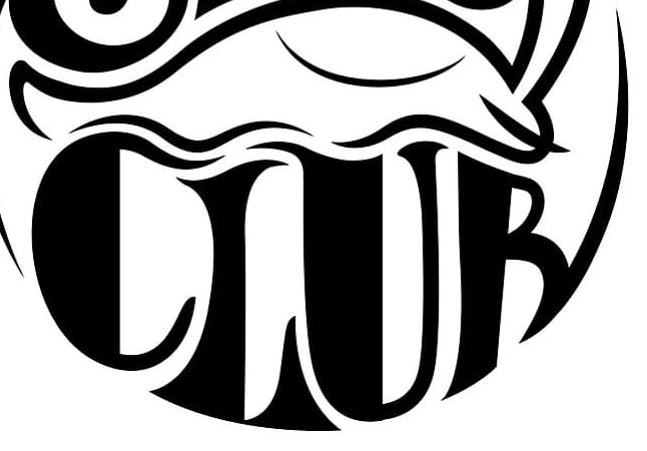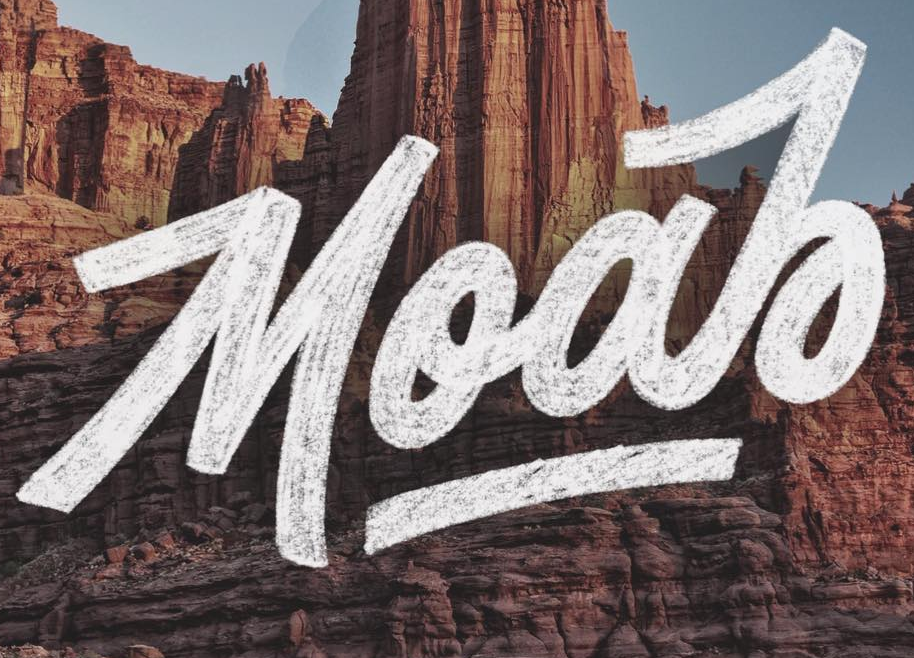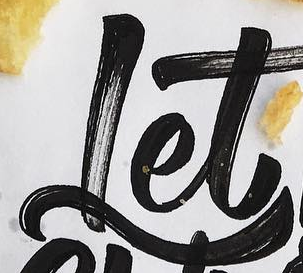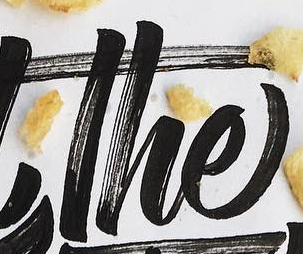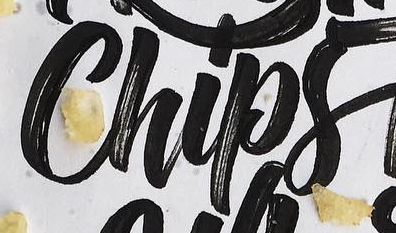What text appears in these images from left to right, separated by a semicolon? CLUB; MooJo; Let; The; Chips 